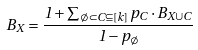Convert formula to latex. <formula><loc_0><loc_0><loc_500><loc_500>B _ { X } = \frac { 1 + \sum _ { \emptyset \subset C \subseteq [ k ] } p _ { C } \cdot B _ { X \cup C } } { 1 - p _ { \emptyset } }</formula> 